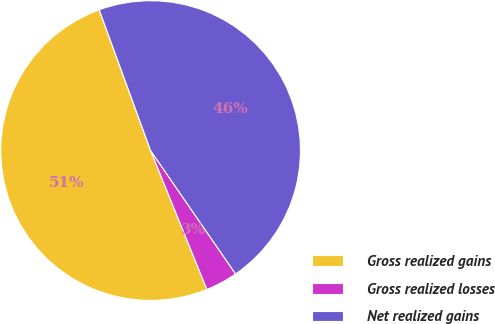Convert chart to OTSL. <chart><loc_0><loc_0><loc_500><loc_500><pie_chart><fcel>Gross realized gains<fcel>Gross realized losses<fcel>Net realized gains<nl><fcel>50.56%<fcel>3.47%<fcel>45.97%<nl></chart> 